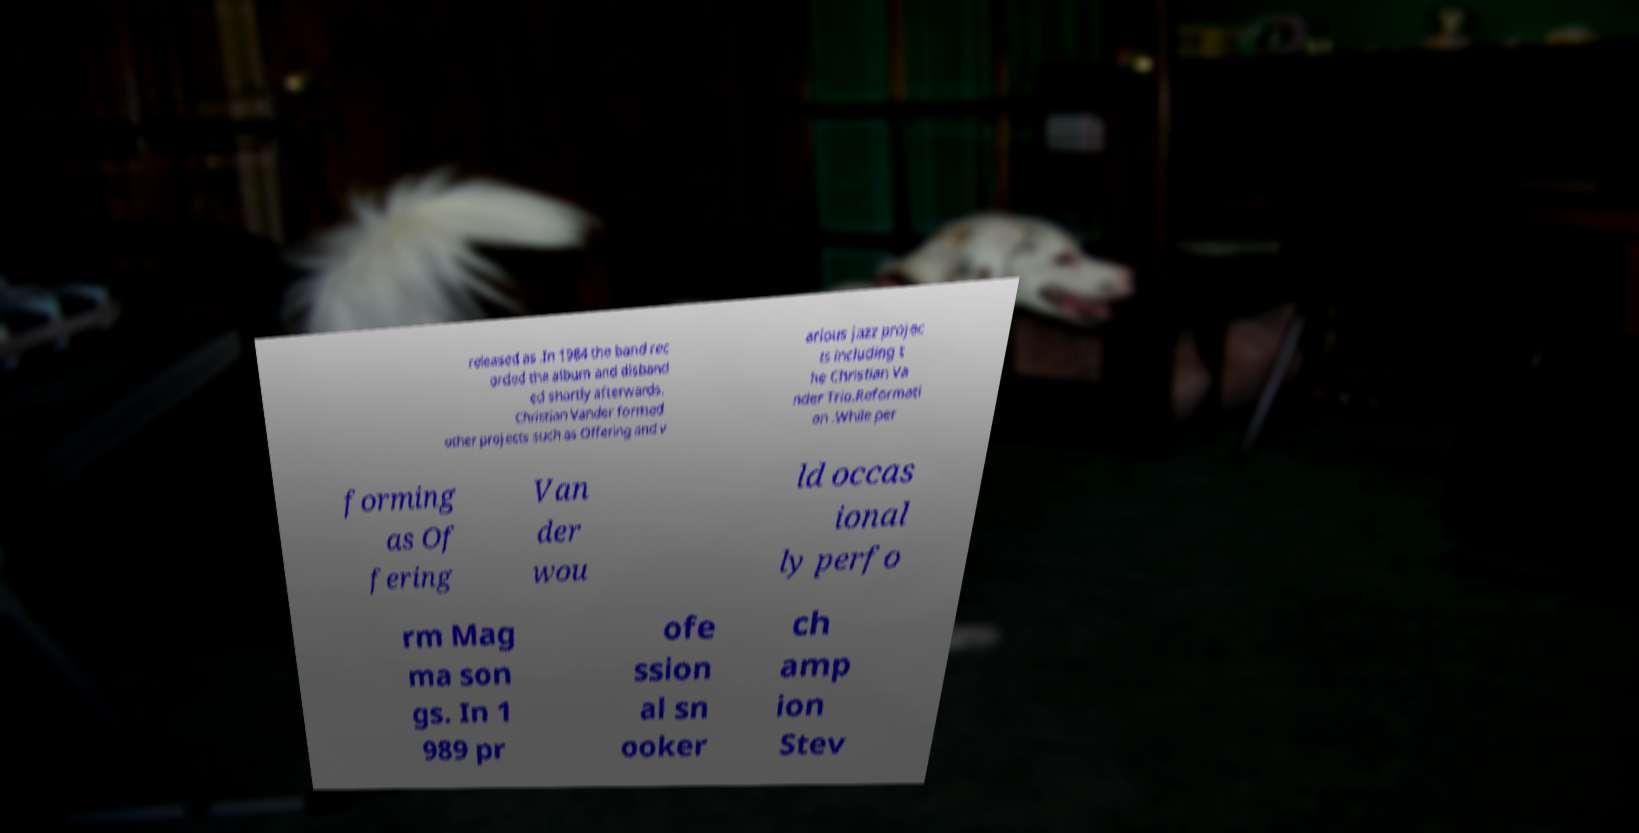What messages or text are displayed in this image? I need them in a readable, typed format. released as .In 1984 the band rec orded the album and disband ed shortly afterwards. Christian Vander formed other projects such as Offering and v arious jazz projec ts including t he Christian Va nder Trio.Reformati on .While per forming as Of fering Van der wou ld occas ional ly perfo rm Mag ma son gs. In 1 989 pr ofe ssion al sn ooker ch amp ion Stev 